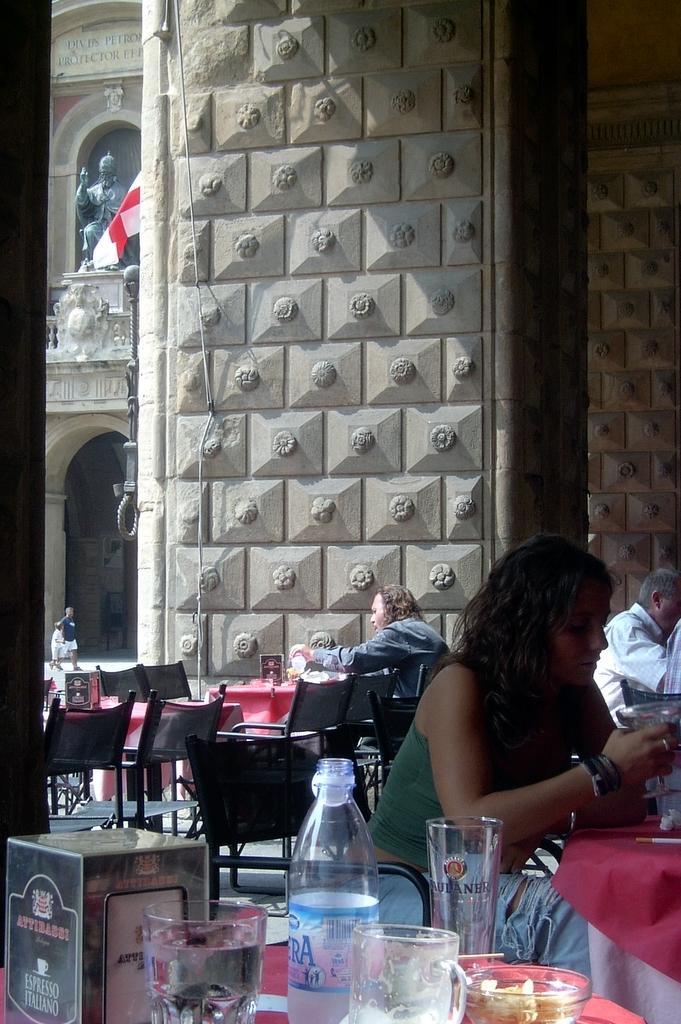Can you describe this image briefly? There is a room with lot of chairs and tables and crowd sitting on them. There is a sculpture on the first floor and flag hanging in front of that. 